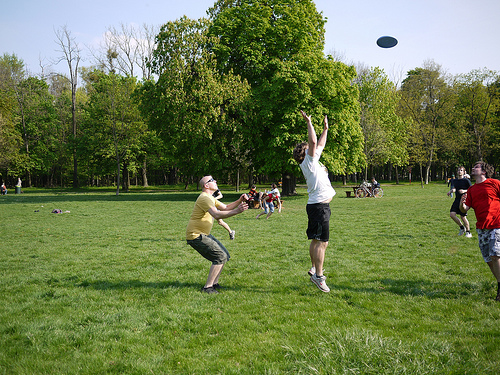What do both the sky and the frisbee have in common? Both the sky and the frisbee share a similar blue color. 